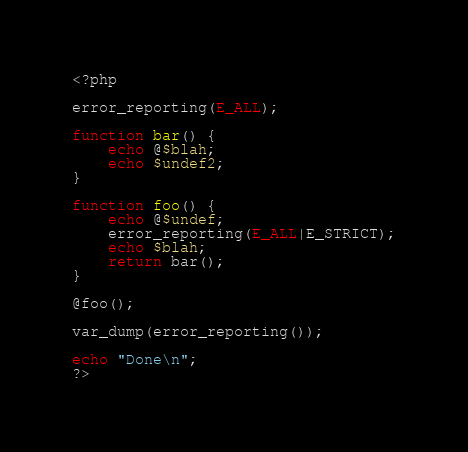Convert code to text. <code><loc_0><loc_0><loc_500><loc_500><_PHP_><?php

error_reporting(E_ALL);
	
function bar() {
	echo @$blah;
	echo $undef2;
}

function foo() {
	echo @$undef;
	error_reporting(E_ALL|E_STRICT);
	echo $blah;
	return bar();
}
	
@foo();					

var_dump(error_reporting());

echo "Done\n";
?>
</code> 